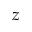Convert formula to latex. <formula><loc_0><loc_0><loc_500><loc_500>z</formula> 